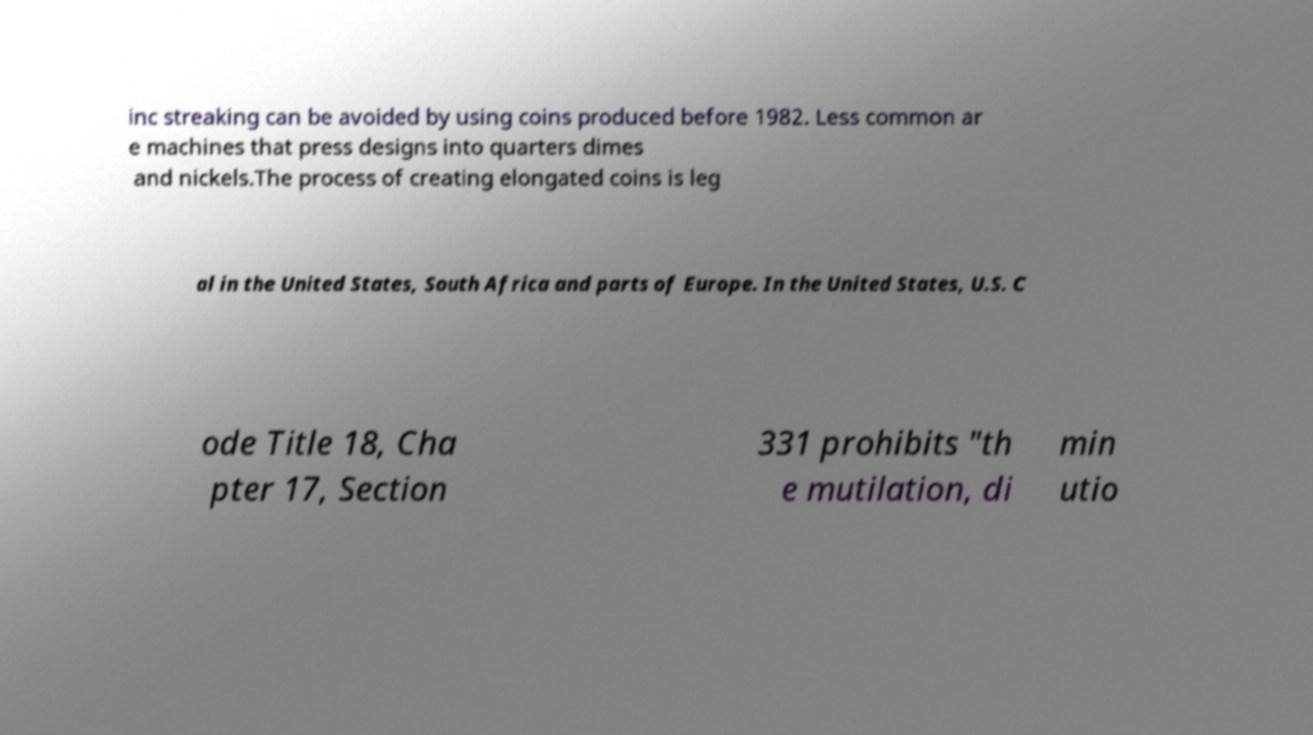There's text embedded in this image that I need extracted. Can you transcribe it verbatim? inc streaking can be avoided by using coins produced before 1982. Less common ar e machines that press designs into quarters dimes and nickels.The process of creating elongated coins is leg al in the United States, South Africa and parts of Europe. In the United States, U.S. C ode Title 18, Cha pter 17, Section 331 prohibits "th e mutilation, di min utio 